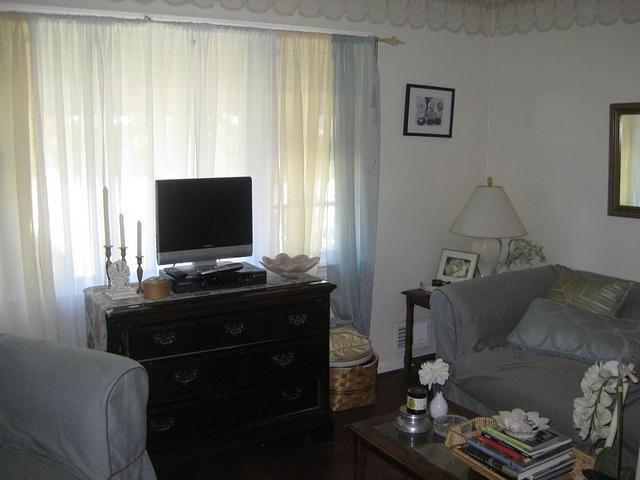How many people are in the scene?
Give a very brief answer. 0. How many candles are there?
Give a very brief answer. 3. How many people have long hair?
Give a very brief answer. 0. 